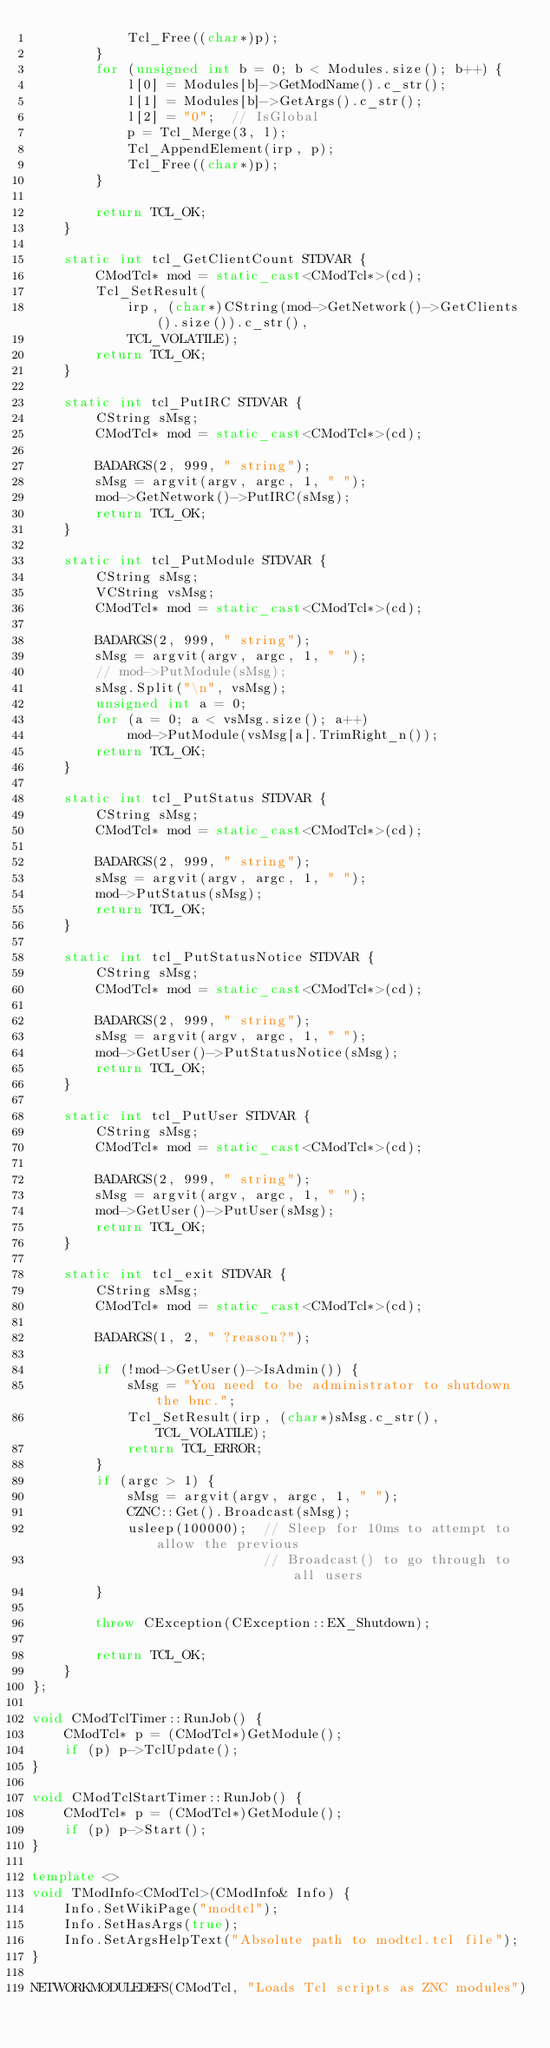Convert code to text. <code><loc_0><loc_0><loc_500><loc_500><_C++_>            Tcl_Free((char*)p);
        }
        for (unsigned int b = 0; b < Modules.size(); b++) {
            l[0] = Modules[b]->GetModName().c_str();
            l[1] = Modules[b]->GetArgs().c_str();
            l[2] = "0";  // IsGlobal
            p = Tcl_Merge(3, l);
            Tcl_AppendElement(irp, p);
            Tcl_Free((char*)p);
        }

        return TCL_OK;
    }

    static int tcl_GetClientCount STDVAR {
        CModTcl* mod = static_cast<CModTcl*>(cd);
        Tcl_SetResult(
            irp, (char*)CString(mod->GetNetwork()->GetClients().size()).c_str(),
            TCL_VOLATILE);
        return TCL_OK;
    }

    static int tcl_PutIRC STDVAR {
        CString sMsg;
        CModTcl* mod = static_cast<CModTcl*>(cd);

        BADARGS(2, 999, " string");
        sMsg = argvit(argv, argc, 1, " ");
        mod->GetNetwork()->PutIRC(sMsg);
        return TCL_OK;
    }

    static int tcl_PutModule STDVAR {
        CString sMsg;
        VCString vsMsg;
        CModTcl* mod = static_cast<CModTcl*>(cd);

        BADARGS(2, 999, " string");
        sMsg = argvit(argv, argc, 1, " ");
        // mod->PutModule(sMsg);
        sMsg.Split("\n", vsMsg);
        unsigned int a = 0;
        for (a = 0; a < vsMsg.size(); a++)
            mod->PutModule(vsMsg[a].TrimRight_n());
        return TCL_OK;
    }

    static int tcl_PutStatus STDVAR {
        CString sMsg;
        CModTcl* mod = static_cast<CModTcl*>(cd);

        BADARGS(2, 999, " string");
        sMsg = argvit(argv, argc, 1, " ");
        mod->PutStatus(sMsg);
        return TCL_OK;
    }

    static int tcl_PutStatusNotice STDVAR {
        CString sMsg;
        CModTcl* mod = static_cast<CModTcl*>(cd);

        BADARGS(2, 999, " string");
        sMsg = argvit(argv, argc, 1, " ");
        mod->GetUser()->PutStatusNotice(sMsg);
        return TCL_OK;
    }

    static int tcl_PutUser STDVAR {
        CString sMsg;
        CModTcl* mod = static_cast<CModTcl*>(cd);

        BADARGS(2, 999, " string");
        sMsg = argvit(argv, argc, 1, " ");
        mod->GetUser()->PutUser(sMsg);
        return TCL_OK;
    }

    static int tcl_exit STDVAR {
        CString sMsg;
        CModTcl* mod = static_cast<CModTcl*>(cd);

        BADARGS(1, 2, " ?reason?");

        if (!mod->GetUser()->IsAdmin()) {
            sMsg = "You need to be administrator to shutdown the bnc.";
            Tcl_SetResult(irp, (char*)sMsg.c_str(), TCL_VOLATILE);
            return TCL_ERROR;
        }
        if (argc > 1) {
            sMsg = argvit(argv, argc, 1, " ");
            CZNC::Get().Broadcast(sMsg);
            usleep(100000);  // Sleep for 10ms to attempt to allow the previous
                             // Broadcast() to go through to all users
        }

        throw CException(CException::EX_Shutdown);

        return TCL_OK;
    }
};

void CModTclTimer::RunJob() {
    CModTcl* p = (CModTcl*)GetModule();
    if (p) p->TclUpdate();
}

void CModTclStartTimer::RunJob() {
    CModTcl* p = (CModTcl*)GetModule();
    if (p) p->Start();
}

template <>
void TModInfo<CModTcl>(CModInfo& Info) {
    Info.SetWikiPage("modtcl");
    Info.SetHasArgs(true);
    Info.SetArgsHelpText("Absolute path to modtcl.tcl file");
}

NETWORKMODULEDEFS(CModTcl, "Loads Tcl scripts as ZNC modules")
</code> 